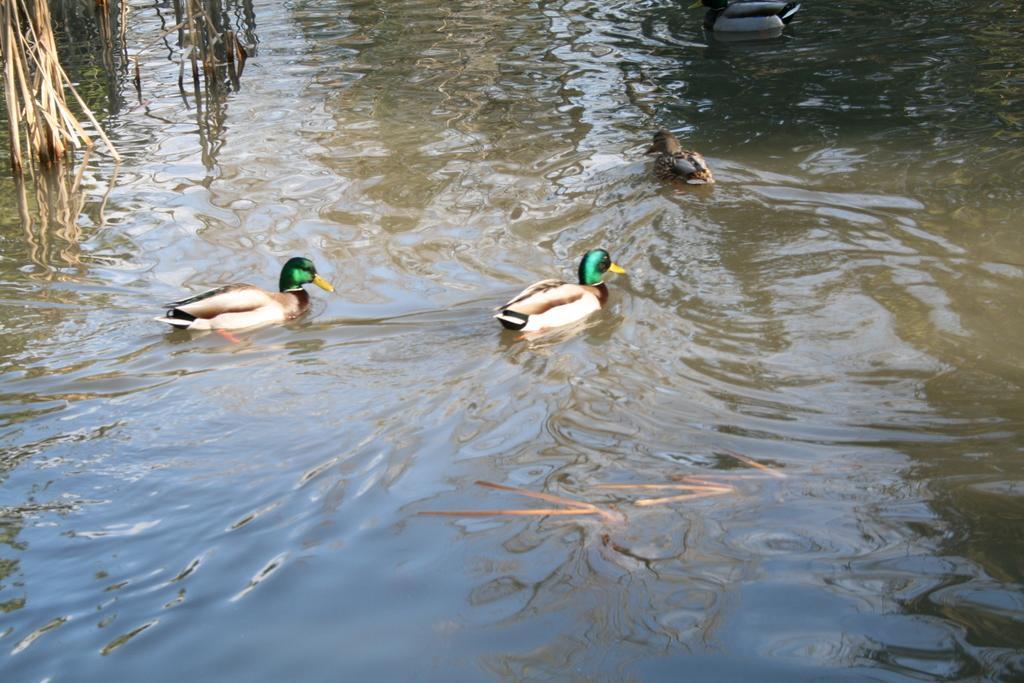Describe this image in one or two sentences. In this image we can see ducks in the water. 